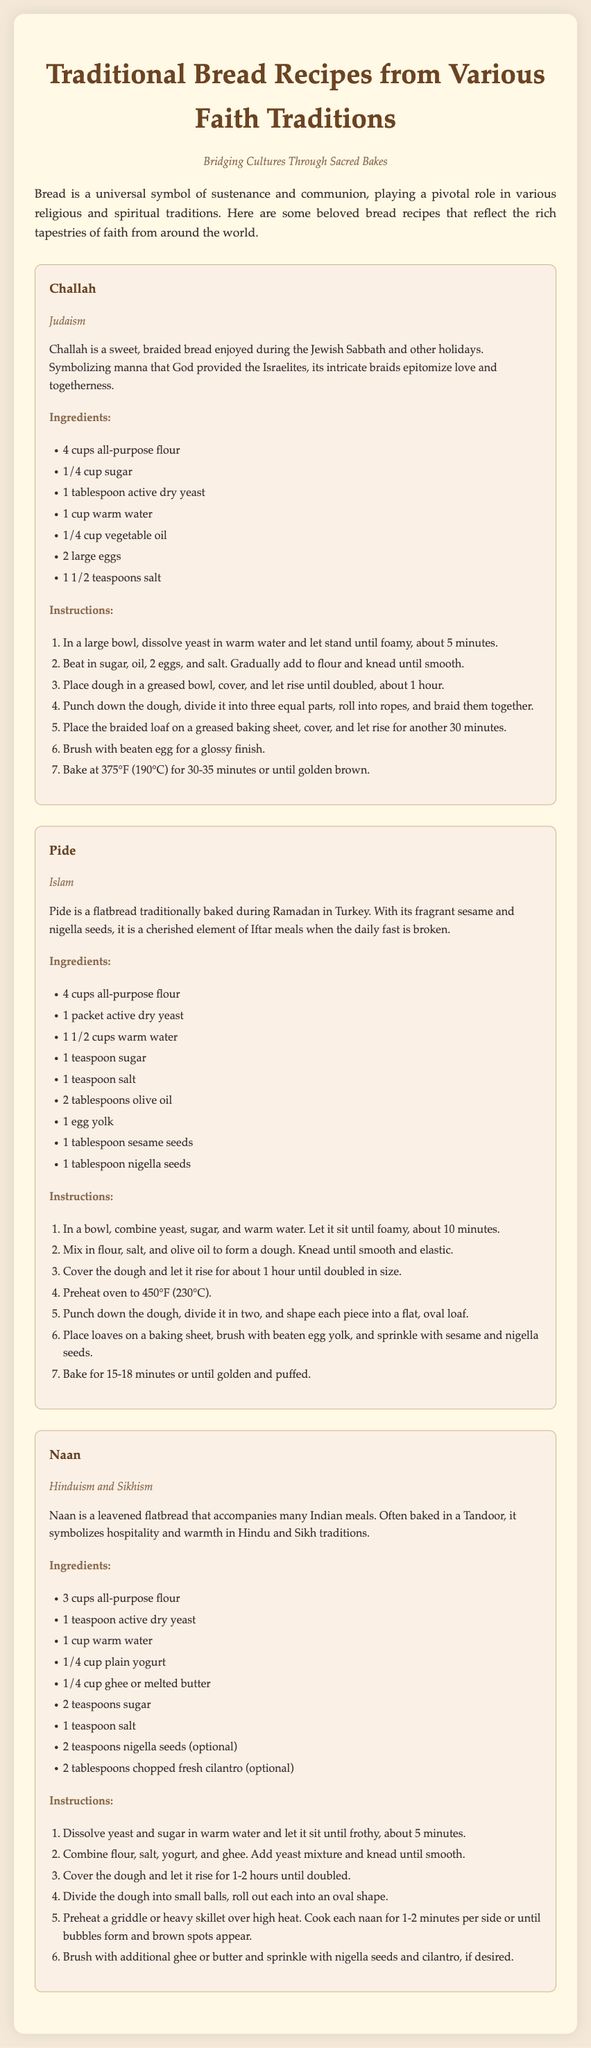What is the primary ingredient in Challah? The primary ingredient in Challah is all-purpose flour, as listed first in the ingredients section.
Answer: 4 cups all-purpose flour How long does the dough for Pide need to rise? The dough for Pide is mentioned to rise for about 1 hour until doubled in size.
Answer: 1 hour What ingredient gives Naan its distinctive flavor? The distinct flavor of Naan comes from the addition of yogurt, as specified in the ingredients list.
Answer: Yogurt Which religious tradition is associated with the bread Pide? Pide is associated with the Islamic faith, as indicated in the document.
Answer: Islam How many eggs are used in the recipe for Challah? The recipe for Challah specifies the use of 2 large eggs.
Answer: 2 large eggs What is the baking temperature for Challah? The baking temperature for Challah is listed as 375°F (190°C).
Answer: 375°F (190°C) What type of seeds are optional for Naan? The optional seeds for Naan are nigella seeds, as mentioned in the ingredients.
Answer: Nigella seeds What is the significance of bread in the context of this document? The document states that bread is a universal symbol of sustenance and communion across various religious traditions.
Answer: Sustenance and communion 